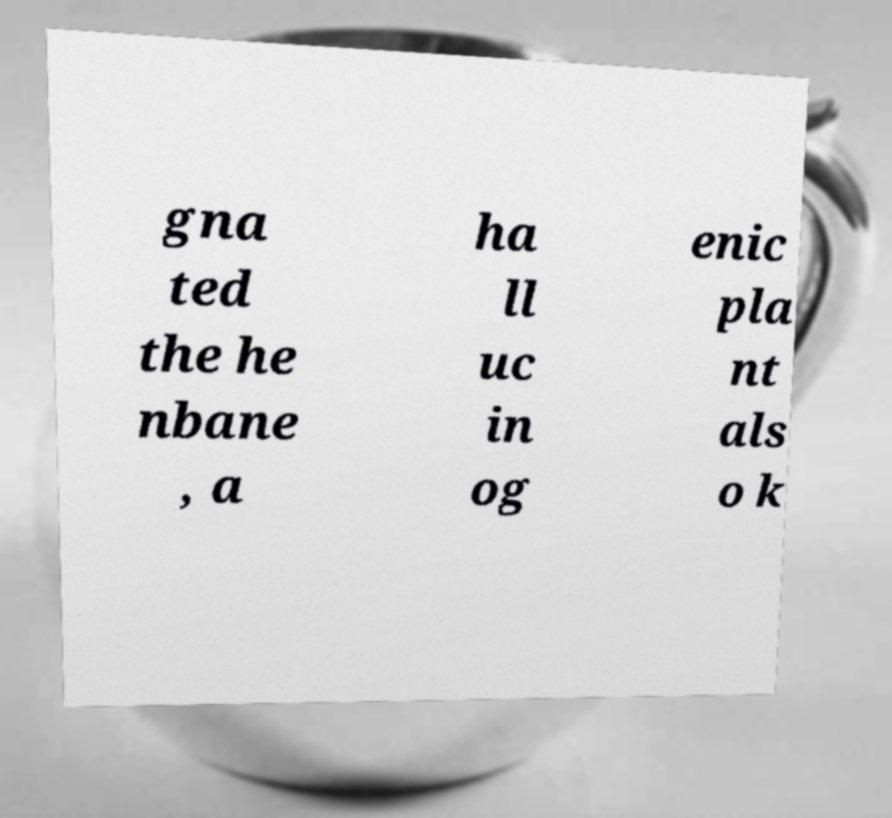Please read and relay the text visible in this image. What does it say? gna ted the he nbane , a ha ll uc in og enic pla nt als o k 